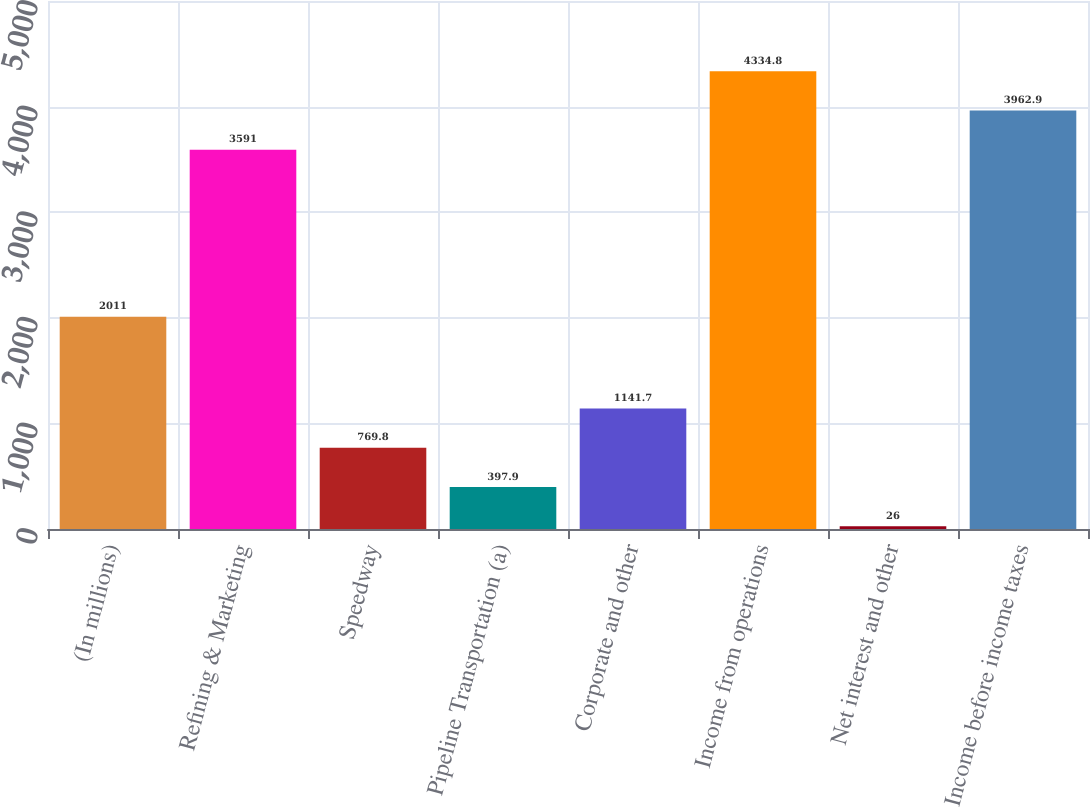<chart> <loc_0><loc_0><loc_500><loc_500><bar_chart><fcel>(In millions)<fcel>Refining & Marketing<fcel>Speedway<fcel>Pipeline Transportation (a)<fcel>Corporate and other<fcel>Income from operations<fcel>Net interest and other<fcel>Income before income taxes<nl><fcel>2011<fcel>3591<fcel>769.8<fcel>397.9<fcel>1141.7<fcel>4334.8<fcel>26<fcel>3962.9<nl></chart> 